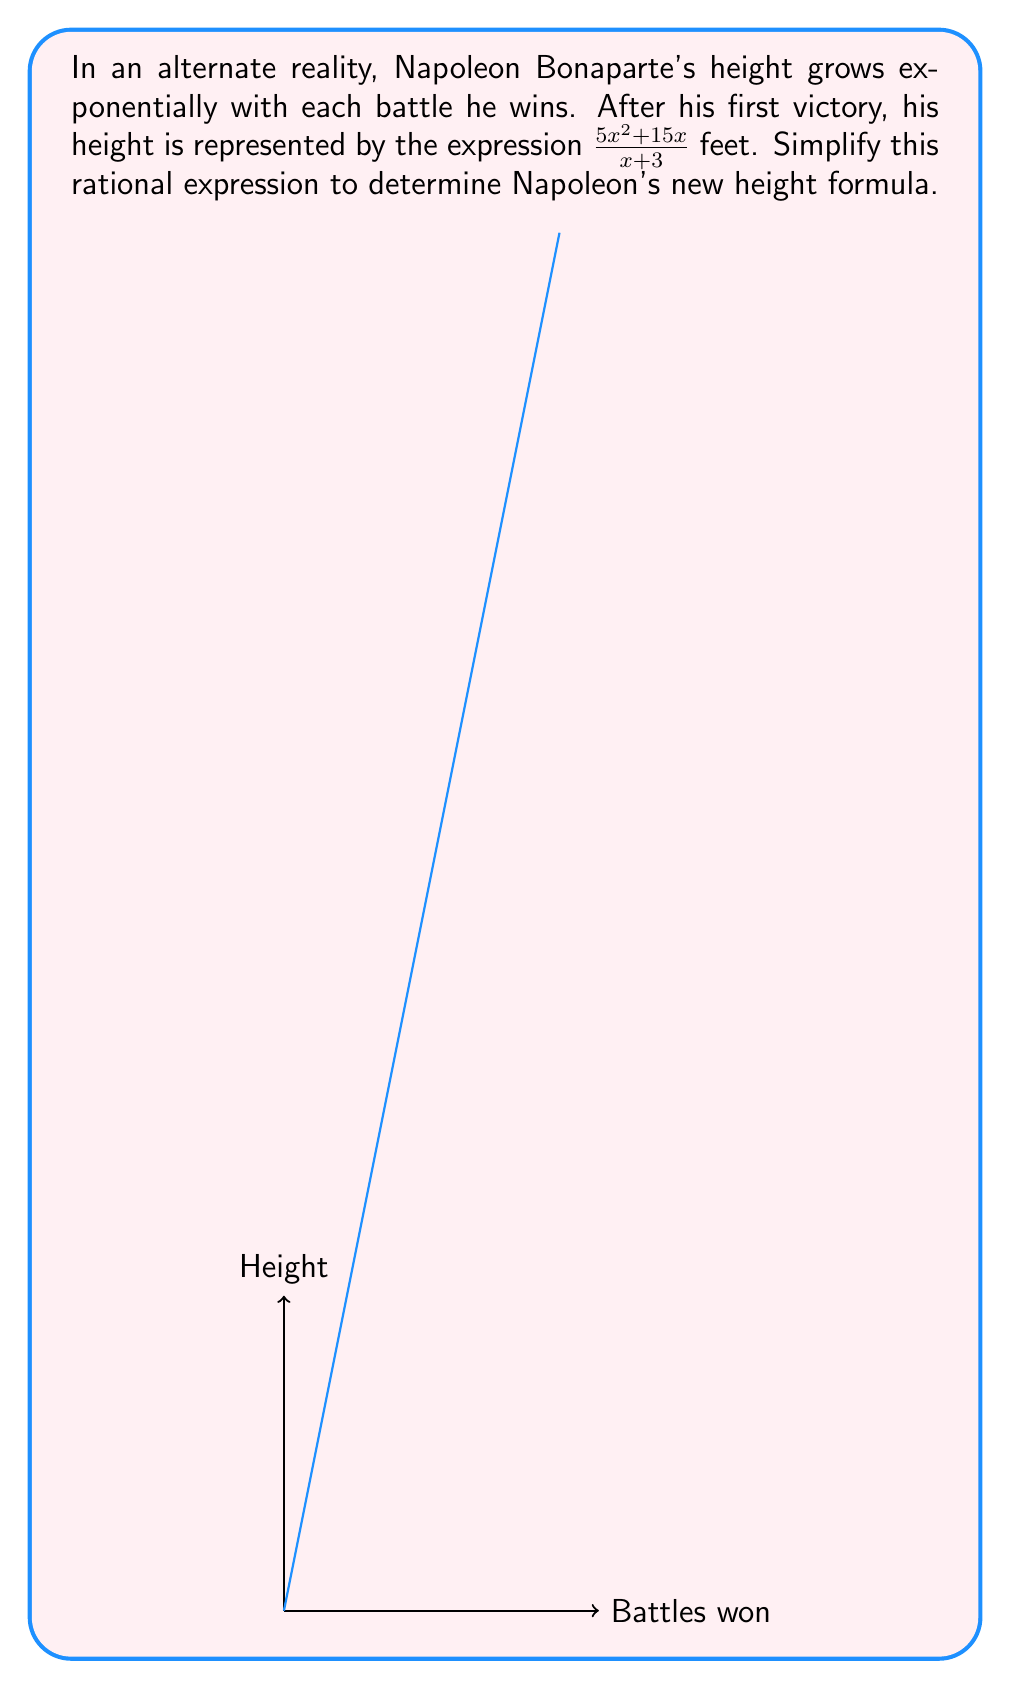Could you help me with this problem? Let's simplify the rational expression $\frac{5x^2 + 15x}{x + 3}$ step by step:

1) First, we need to factor the numerator:
   $5x^2 + 15x = 5x(x + 3)$

2) Now our expression looks like this:
   $\frac{5x(x + 3)}{x + 3}$

3) We can see that $(x + 3)$ appears in both the numerator and denominator. This means we can cancel it out:

   $\frac{5x\cancel{(x + 3)}}{\cancel{x + 3}}$

4) After cancellation, we're left with:
   $5x$

Therefore, Napoleon's new height formula simplifies to $5x$ feet.
Answer: $5x$ feet 